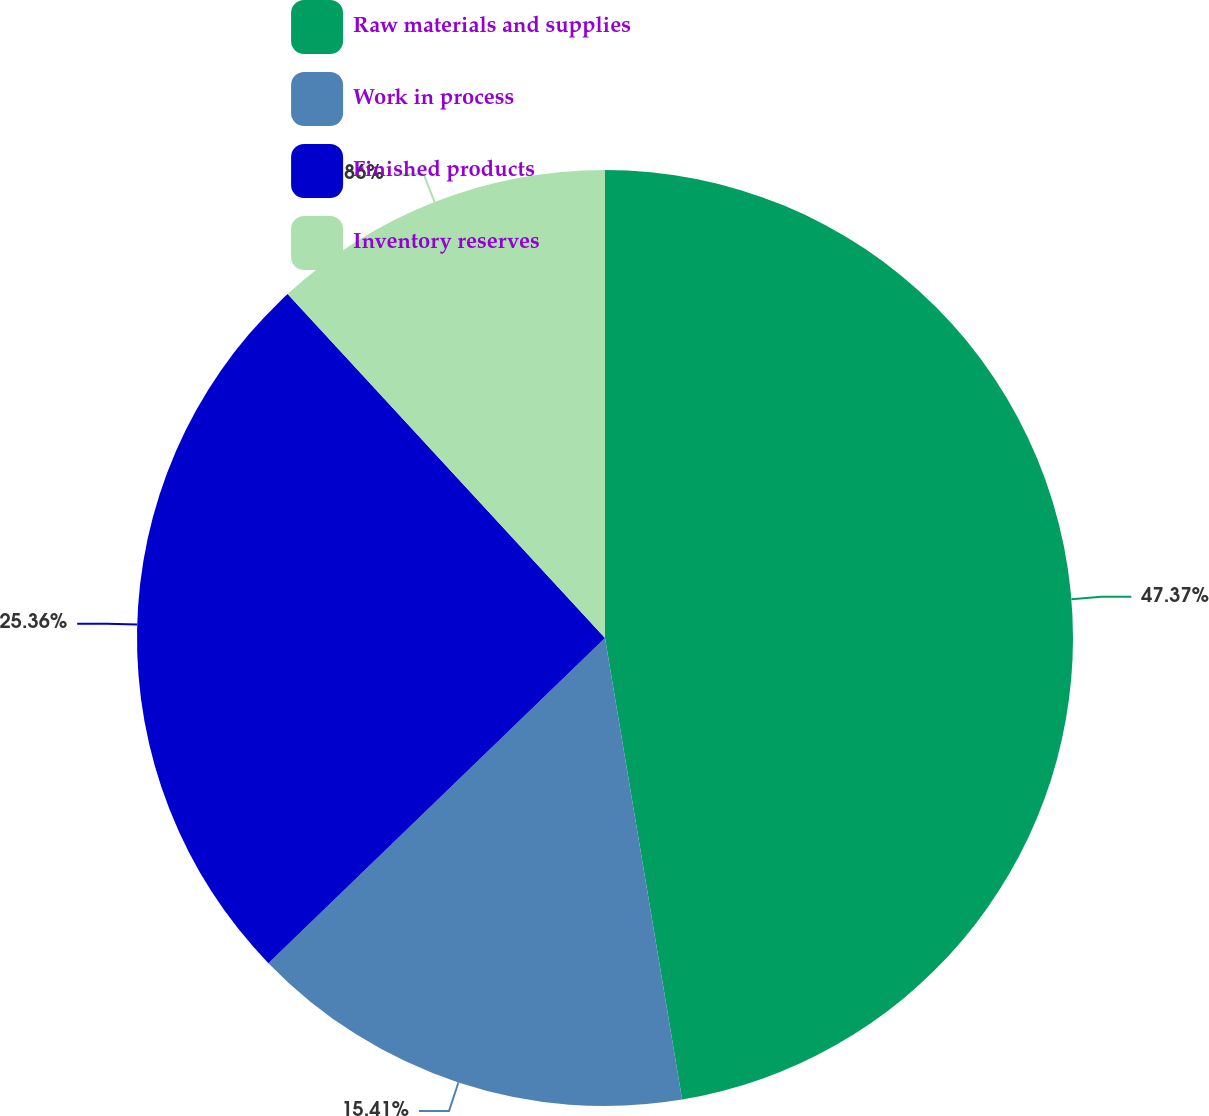<chart> <loc_0><loc_0><loc_500><loc_500><pie_chart><fcel>Raw materials and supplies<fcel>Work in process<fcel>Finished products<fcel>Inventory reserves<nl><fcel>47.36%<fcel>15.41%<fcel>25.36%<fcel>11.86%<nl></chart> 